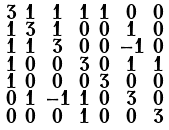Convert formula to latex. <formula><loc_0><loc_0><loc_500><loc_500>\begin{smallmatrix} 3 & 1 & 1 & 1 & 1 & 0 & 0 \\ 1 & 3 & 1 & 0 & 0 & 1 & 0 \\ 1 & 1 & 3 & 0 & 0 & - 1 & 0 \\ 1 & 0 & 0 & 3 & 0 & 1 & 1 \\ 1 & 0 & 0 & 0 & 3 & 0 & 0 \\ 0 & 1 & - 1 & 1 & 0 & 3 & 0 \\ 0 & 0 & 0 & 1 & 0 & 0 & 3 \end{smallmatrix}</formula> 